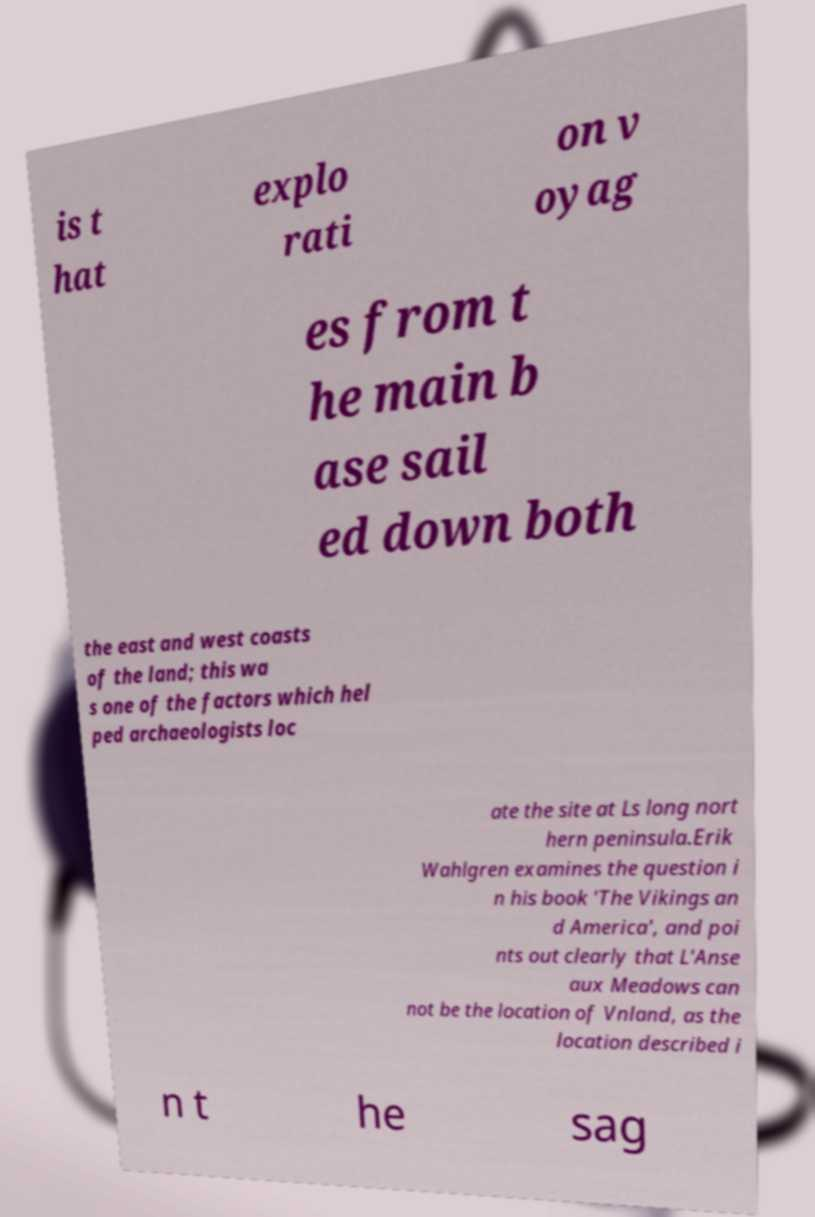I need the written content from this picture converted into text. Can you do that? is t hat explo rati on v oyag es from t he main b ase sail ed down both the east and west coasts of the land; this wa s one of the factors which hel ped archaeologists loc ate the site at Ls long nort hern peninsula.Erik Wahlgren examines the question i n his book 'The Vikings an d America', and poi nts out clearly that L'Anse aux Meadows can not be the location of Vnland, as the location described i n t he sag 